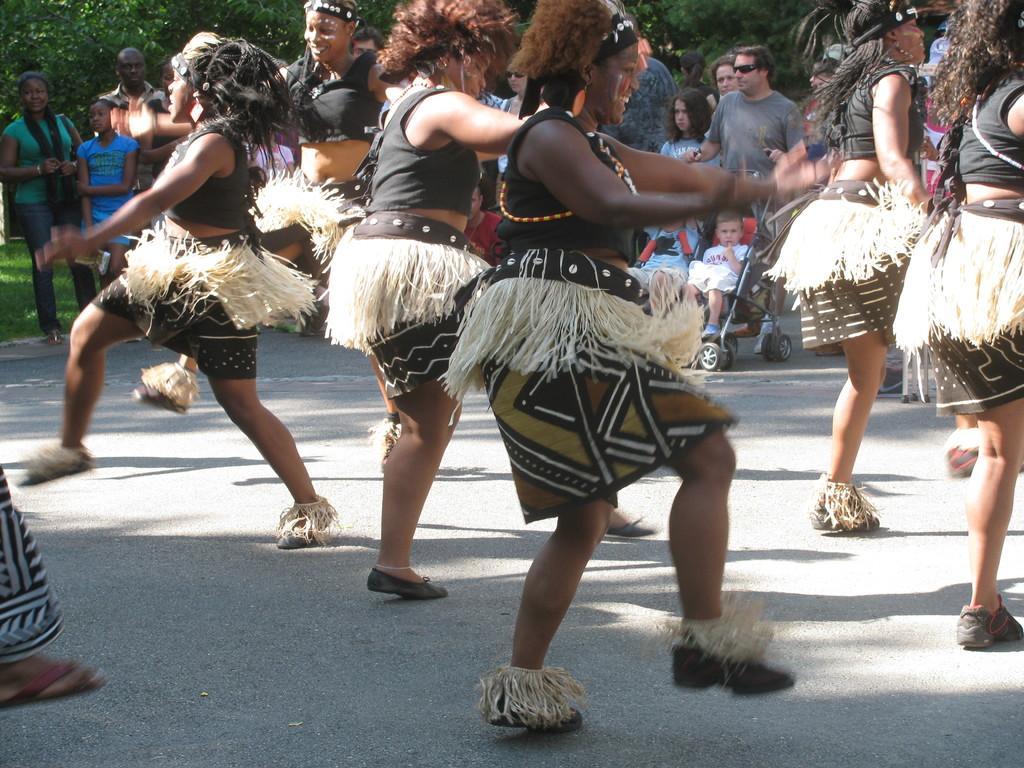Could you give a brief overview of what you see in this image? In this picture we can see a group of people where some are standing and some are dancing on the road, stroller with a child in it and in the background we can see trees. 